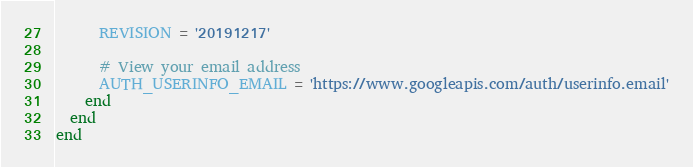<code> <loc_0><loc_0><loc_500><loc_500><_Ruby_>      REVISION = '20191217'

      # View your email address
      AUTH_USERINFO_EMAIL = 'https://www.googleapis.com/auth/userinfo.email'
    end
  end
end
</code> 